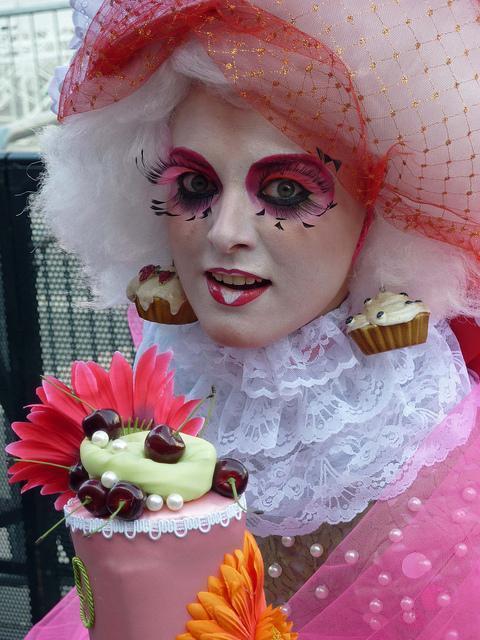How many cakes are there?
Give a very brief answer. 3. 